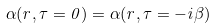Convert formula to latex. <formula><loc_0><loc_0><loc_500><loc_500>\alpha ( r , \tau = 0 ) = \alpha ( r , \tau = - i \beta )</formula> 